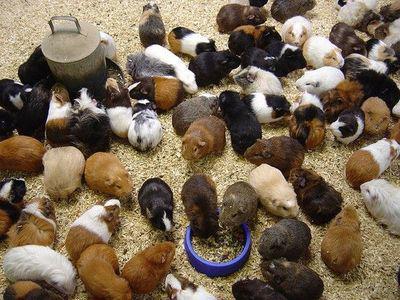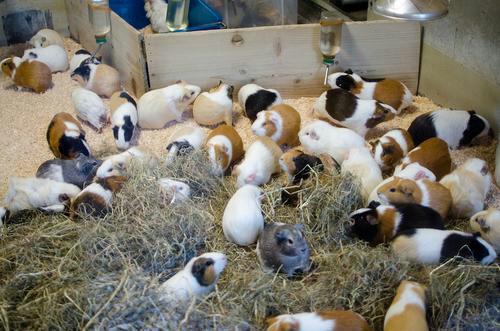The first image is the image on the left, the second image is the image on the right. Assess this claim about the two images: "The animals in the image on the left are not in an enclosure.". Correct or not? Answer yes or no. Yes. 